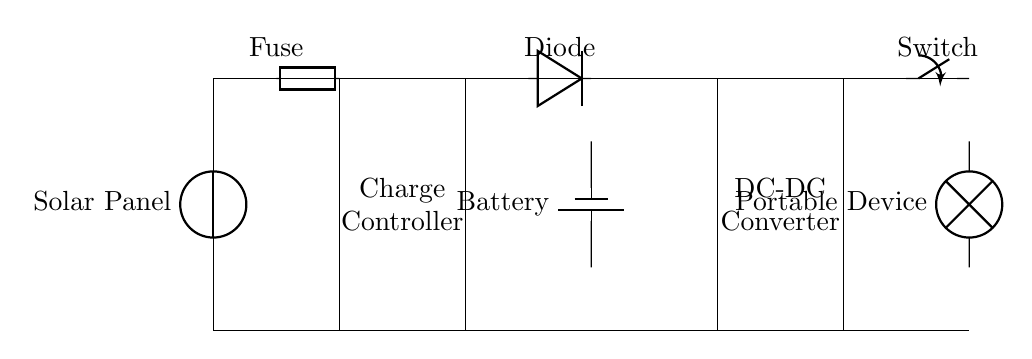What is the main energy source for this circuit? The circuit primarily uses solar energy as indicated by the solar panel component shown at the beginning of the circuit diagram.
Answer: Solar Panel What component prevents reverse current flow? The diode, represented in the circuit diagram, is specifically designed to allow current to flow in one direction and block it in the opposite direction, thus preventing reverse current flow.
Answer: Diode What is the role of the charge controller in this circuit? The charge controller regulates the charge going into the battery from the solar panel, ensuring that the battery is charged efficiently and preventing overcharging.
Answer: Regulates charging How many primary components are shown in the circuit diagram? Counting the solar panel, charge controller, battery, DC-DC converter, and portable device gives us five primary components.
Answer: Five What could happen without the fuse in this circuit? If the fuse were absent, the circuit would lack protection against overpowering currents, which could lead to damage in sensitive components like the battery or other circuitry.
Answer: Overheating What is the function of the DC-DC converter? The DC-DC converter adjusts the voltage output from the battery to match the voltage requirements of the portable device being charged.
Answer: Voltage adjustment Why is a switch included in this circuit design? The switch allows users to turn the circuit on or off, providing control over whether the battery supplies power to the portable device, which is essential for managing energy use.
Answer: Control power flow 